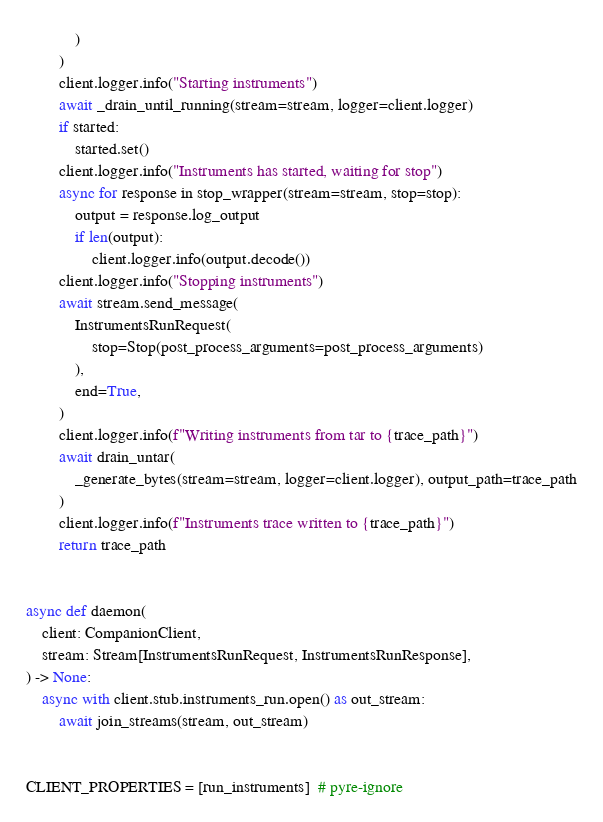Convert code to text. <code><loc_0><loc_0><loc_500><loc_500><_Python_>            )
        )
        client.logger.info("Starting instruments")
        await _drain_until_running(stream=stream, logger=client.logger)
        if started:
            started.set()
        client.logger.info("Instruments has started, waiting for stop")
        async for response in stop_wrapper(stream=stream, stop=stop):
            output = response.log_output
            if len(output):
                client.logger.info(output.decode())
        client.logger.info("Stopping instruments")
        await stream.send_message(
            InstrumentsRunRequest(
                stop=Stop(post_process_arguments=post_process_arguments)
            ),
            end=True,
        )
        client.logger.info(f"Writing instruments from tar to {trace_path}")
        await drain_untar(
            _generate_bytes(stream=stream, logger=client.logger), output_path=trace_path
        )
        client.logger.info(f"Instruments trace written to {trace_path}")
        return trace_path


async def daemon(
    client: CompanionClient,
    stream: Stream[InstrumentsRunRequest, InstrumentsRunResponse],
) -> None:
    async with client.stub.instruments_run.open() as out_stream:
        await join_streams(stream, out_stream)


CLIENT_PROPERTIES = [run_instruments]  # pyre-ignore
</code> 